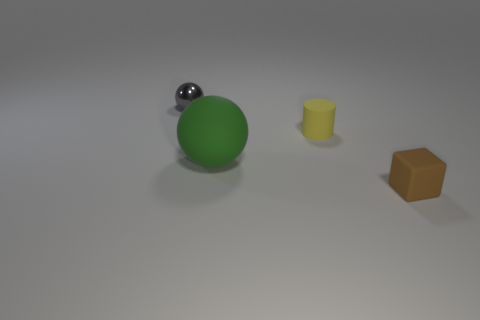Add 4 yellow matte cylinders. How many objects exist? 8 Subtract all cylinders. How many objects are left? 3 Add 2 big green objects. How many big green objects are left? 3 Add 3 yellow cylinders. How many yellow cylinders exist? 4 Subtract 1 brown cubes. How many objects are left? 3 Subtract all shiny blocks. Subtract all tiny metallic objects. How many objects are left? 3 